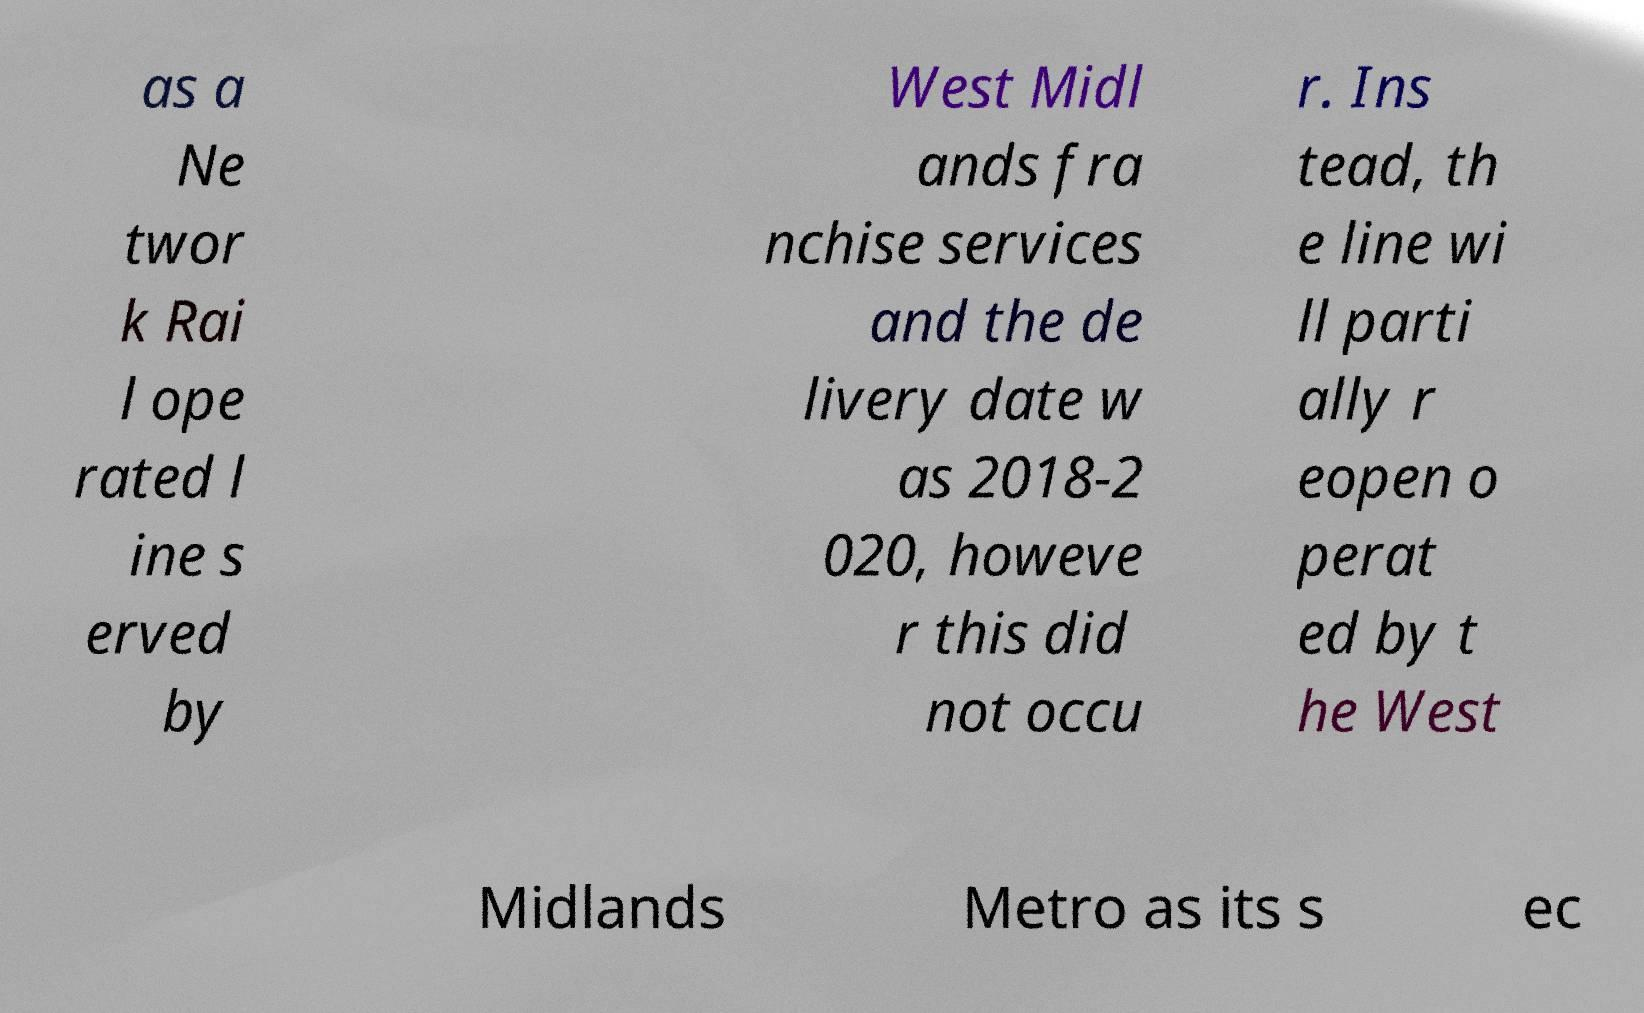I need the written content from this picture converted into text. Can you do that? as a Ne twor k Rai l ope rated l ine s erved by West Midl ands fra nchise services and the de livery date w as 2018-2 020, howeve r this did not occu r. Ins tead, th e line wi ll parti ally r eopen o perat ed by t he West Midlands Metro as its s ec 